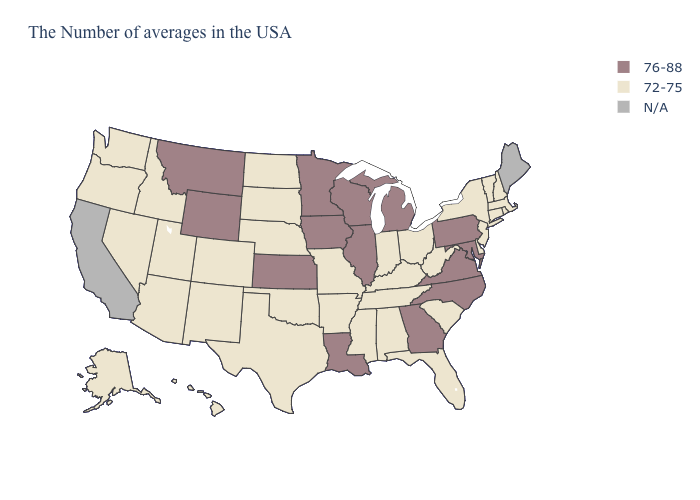Name the states that have a value in the range 76-88?
Quick response, please. Maryland, Pennsylvania, Virginia, North Carolina, Georgia, Michigan, Wisconsin, Illinois, Louisiana, Minnesota, Iowa, Kansas, Wyoming, Montana. Name the states that have a value in the range 72-75?
Concise answer only. Massachusetts, Rhode Island, New Hampshire, Vermont, Connecticut, New York, New Jersey, Delaware, South Carolina, West Virginia, Ohio, Florida, Kentucky, Indiana, Alabama, Tennessee, Mississippi, Missouri, Arkansas, Nebraska, Oklahoma, Texas, South Dakota, North Dakota, Colorado, New Mexico, Utah, Arizona, Idaho, Nevada, Washington, Oregon, Alaska, Hawaii. Name the states that have a value in the range 76-88?
Be succinct. Maryland, Pennsylvania, Virginia, North Carolina, Georgia, Michigan, Wisconsin, Illinois, Louisiana, Minnesota, Iowa, Kansas, Wyoming, Montana. What is the value of Arizona?
Answer briefly. 72-75. Name the states that have a value in the range N/A?
Concise answer only. Maine, California. Name the states that have a value in the range N/A?
Answer briefly. Maine, California. Name the states that have a value in the range 72-75?
Answer briefly. Massachusetts, Rhode Island, New Hampshire, Vermont, Connecticut, New York, New Jersey, Delaware, South Carolina, West Virginia, Ohio, Florida, Kentucky, Indiana, Alabama, Tennessee, Mississippi, Missouri, Arkansas, Nebraska, Oklahoma, Texas, South Dakota, North Dakota, Colorado, New Mexico, Utah, Arizona, Idaho, Nevada, Washington, Oregon, Alaska, Hawaii. What is the value of Colorado?
Short answer required. 72-75. Which states have the highest value in the USA?
Concise answer only. Maryland, Pennsylvania, Virginia, North Carolina, Georgia, Michigan, Wisconsin, Illinois, Louisiana, Minnesota, Iowa, Kansas, Wyoming, Montana. What is the value of Tennessee?
Give a very brief answer. 72-75. What is the value of North Carolina?
Be succinct. 76-88. Name the states that have a value in the range 72-75?
Be succinct. Massachusetts, Rhode Island, New Hampshire, Vermont, Connecticut, New York, New Jersey, Delaware, South Carolina, West Virginia, Ohio, Florida, Kentucky, Indiana, Alabama, Tennessee, Mississippi, Missouri, Arkansas, Nebraska, Oklahoma, Texas, South Dakota, North Dakota, Colorado, New Mexico, Utah, Arizona, Idaho, Nevada, Washington, Oregon, Alaska, Hawaii. What is the value of Ohio?
Concise answer only. 72-75. Name the states that have a value in the range N/A?
Write a very short answer. Maine, California. What is the value of Alabama?
Answer briefly. 72-75. 